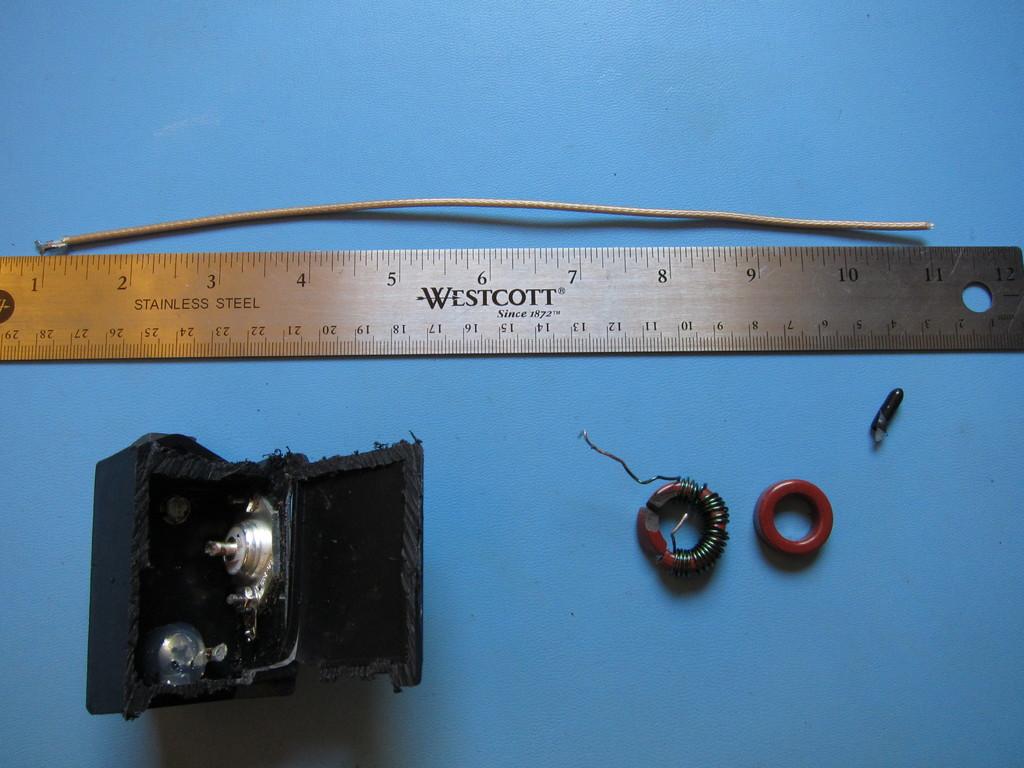What brand is the ruler?
Your response must be concise. Westcott. What is it made of?
Provide a short and direct response. Stainless steel. 